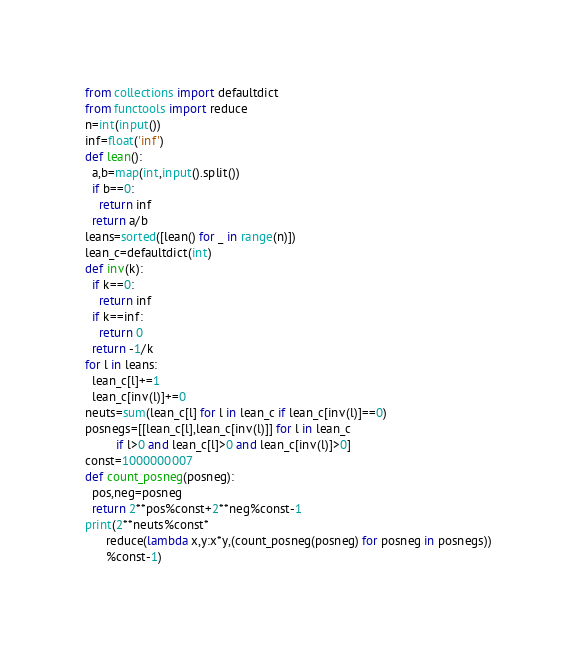<code> <loc_0><loc_0><loc_500><loc_500><_Python_>from collections import defaultdict
from functools import reduce
n=int(input())
inf=float('inf')
def lean():
  a,b=map(int,input().split())
  if b==0:
    return inf
  return a/b
leans=sorted([lean() for _ in range(n)])
lean_c=defaultdict(int)
def inv(k):
  if k==0:
    return inf
  if k==inf:
    return 0
  return -1/k
for l in leans:
  lean_c[l]+=1
  lean_c[inv(l)]+=0
neuts=sum(lean_c[l] for l in lean_c if lean_c[inv(l)]==0)
posnegs=[[lean_c[l],lean_c[inv(l)]] for l in lean_c
         if l>0 and lean_c[l]>0 and lean_c[inv(l)]>0]
const=1000000007
def count_posneg(posneg):
  pos,neg=posneg
  return 2**pos%const+2**neg%const-1
print(2**neuts%const*
      reduce(lambda x,y:x*y,(count_posneg(posneg) for posneg in posnegs))
      %const-1)</code> 